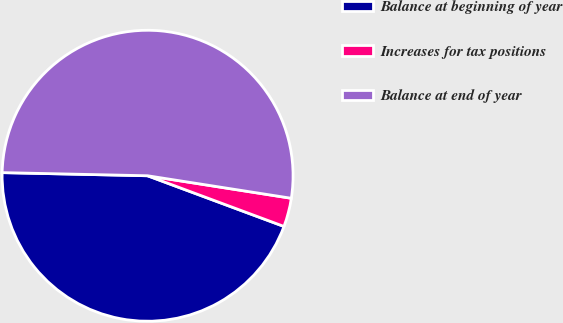<chart> <loc_0><loc_0><loc_500><loc_500><pie_chart><fcel>Balance at beginning of year<fcel>Increases for tax positions<fcel>Balance at end of year<nl><fcel>44.68%<fcel>3.19%<fcel>52.13%<nl></chart> 